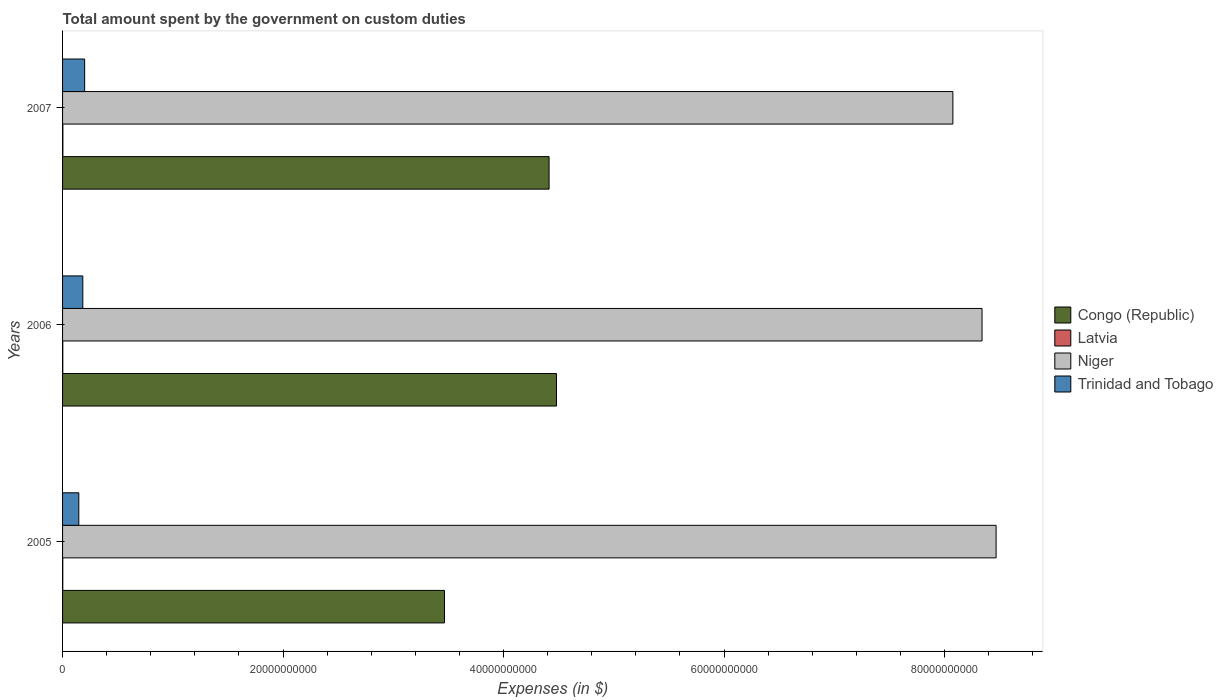Are the number of bars on each tick of the Y-axis equal?
Keep it short and to the point. Yes. How many bars are there on the 2nd tick from the bottom?
Your response must be concise. 4. What is the label of the 3rd group of bars from the top?
Your answer should be compact. 2005. In how many cases, is the number of bars for a given year not equal to the number of legend labels?
Your answer should be compact. 0. What is the amount spent on custom duties by the government in Congo (Republic) in 2005?
Offer a very short reply. 3.46e+1. Across all years, what is the maximum amount spent on custom duties by the government in Niger?
Keep it short and to the point. 8.47e+1. Across all years, what is the minimum amount spent on custom duties by the government in Congo (Republic)?
Your answer should be very brief. 3.46e+1. In which year was the amount spent on custom duties by the government in Congo (Republic) maximum?
Offer a very short reply. 2006. In which year was the amount spent on custom duties by the government in Congo (Republic) minimum?
Your answer should be compact. 2005. What is the total amount spent on custom duties by the government in Trinidad and Tobago in the graph?
Offer a very short reply. 5.31e+09. What is the difference between the amount spent on custom duties by the government in Congo (Republic) in 2005 and that in 2007?
Your answer should be very brief. -9.48e+09. What is the difference between the amount spent on custom duties by the government in Congo (Republic) in 2005 and the amount spent on custom duties by the government in Trinidad and Tobago in 2007?
Offer a very short reply. 3.26e+1. What is the average amount spent on custom duties by the government in Latvia per year?
Provide a short and direct response. 2.26e+07. In the year 2005, what is the difference between the amount spent on custom duties by the government in Niger and amount spent on custom duties by the government in Latvia?
Offer a terse response. 8.47e+1. In how many years, is the amount spent on custom duties by the government in Niger greater than 12000000000 $?
Your answer should be very brief. 3. What is the ratio of the amount spent on custom duties by the government in Trinidad and Tobago in 2005 to that in 2006?
Make the answer very short. 0.8. What is the difference between the highest and the second highest amount spent on custom duties by the government in Latvia?
Offer a very short reply. 7.14e+06. What is the difference between the highest and the lowest amount spent on custom duties by the government in Niger?
Ensure brevity in your answer.  3.92e+09. In how many years, is the amount spent on custom duties by the government in Niger greater than the average amount spent on custom duties by the government in Niger taken over all years?
Your answer should be compact. 2. Is it the case that in every year, the sum of the amount spent on custom duties by the government in Congo (Republic) and amount spent on custom duties by the government in Latvia is greater than the sum of amount spent on custom duties by the government in Niger and amount spent on custom duties by the government in Trinidad and Tobago?
Provide a succinct answer. Yes. What does the 3rd bar from the top in 2005 represents?
Your answer should be very brief. Latvia. What does the 1st bar from the bottom in 2005 represents?
Keep it short and to the point. Congo (Republic). Is it the case that in every year, the sum of the amount spent on custom duties by the government in Trinidad and Tobago and amount spent on custom duties by the government in Niger is greater than the amount spent on custom duties by the government in Latvia?
Offer a terse response. Yes. How many bars are there?
Make the answer very short. 12. What is the difference between two consecutive major ticks on the X-axis?
Give a very brief answer. 2.00e+1. Where does the legend appear in the graph?
Offer a very short reply. Center right. How many legend labels are there?
Keep it short and to the point. 4. What is the title of the graph?
Offer a very short reply. Total amount spent by the government on custom duties. Does "Mauritius" appear as one of the legend labels in the graph?
Offer a terse response. No. What is the label or title of the X-axis?
Make the answer very short. Expenses (in $). What is the Expenses (in $) in Congo (Republic) in 2005?
Keep it short and to the point. 3.46e+1. What is the Expenses (in $) of Latvia in 2005?
Provide a short and direct response. 1.92e+07. What is the Expenses (in $) of Niger in 2005?
Your response must be concise. 8.47e+1. What is the Expenses (in $) of Trinidad and Tobago in 2005?
Your answer should be very brief. 1.47e+09. What is the Expenses (in $) of Congo (Republic) in 2006?
Your response must be concise. 4.48e+1. What is the Expenses (in $) of Latvia in 2006?
Your answer should be very brief. 2.07e+07. What is the Expenses (in $) of Niger in 2006?
Make the answer very short. 8.34e+1. What is the Expenses (in $) of Trinidad and Tobago in 2006?
Offer a terse response. 1.84e+09. What is the Expenses (in $) of Congo (Republic) in 2007?
Provide a short and direct response. 4.41e+1. What is the Expenses (in $) in Latvia in 2007?
Your answer should be very brief. 2.78e+07. What is the Expenses (in $) in Niger in 2007?
Your answer should be compact. 8.08e+1. What is the Expenses (in $) in Trinidad and Tobago in 2007?
Offer a very short reply. 2.00e+09. Across all years, what is the maximum Expenses (in $) in Congo (Republic)?
Offer a terse response. 4.48e+1. Across all years, what is the maximum Expenses (in $) of Latvia?
Your response must be concise. 2.78e+07. Across all years, what is the maximum Expenses (in $) of Niger?
Make the answer very short. 8.47e+1. Across all years, what is the maximum Expenses (in $) in Trinidad and Tobago?
Offer a very short reply. 2.00e+09. Across all years, what is the minimum Expenses (in $) of Congo (Republic)?
Give a very brief answer. 3.46e+1. Across all years, what is the minimum Expenses (in $) in Latvia?
Your answer should be very brief. 1.92e+07. Across all years, what is the minimum Expenses (in $) of Niger?
Offer a terse response. 8.08e+1. Across all years, what is the minimum Expenses (in $) of Trinidad and Tobago?
Keep it short and to the point. 1.47e+09. What is the total Expenses (in $) in Congo (Republic) in the graph?
Keep it short and to the point. 1.24e+11. What is the total Expenses (in $) in Latvia in the graph?
Your answer should be compact. 6.77e+07. What is the total Expenses (in $) of Niger in the graph?
Your answer should be very brief. 2.49e+11. What is the total Expenses (in $) of Trinidad and Tobago in the graph?
Offer a terse response. 5.31e+09. What is the difference between the Expenses (in $) of Congo (Republic) in 2005 and that in 2006?
Provide a short and direct response. -1.02e+1. What is the difference between the Expenses (in $) in Latvia in 2005 and that in 2006?
Ensure brevity in your answer.  -1.50e+06. What is the difference between the Expenses (in $) in Niger in 2005 and that in 2006?
Give a very brief answer. 1.28e+09. What is the difference between the Expenses (in $) of Trinidad and Tobago in 2005 and that in 2006?
Keep it short and to the point. -3.63e+08. What is the difference between the Expenses (in $) in Congo (Republic) in 2005 and that in 2007?
Offer a terse response. -9.48e+09. What is the difference between the Expenses (in $) of Latvia in 2005 and that in 2007?
Give a very brief answer. -8.64e+06. What is the difference between the Expenses (in $) of Niger in 2005 and that in 2007?
Your response must be concise. 3.92e+09. What is the difference between the Expenses (in $) in Trinidad and Tobago in 2005 and that in 2007?
Give a very brief answer. -5.31e+08. What is the difference between the Expenses (in $) in Congo (Republic) in 2006 and that in 2007?
Your response must be concise. 6.73e+08. What is the difference between the Expenses (in $) of Latvia in 2006 and that in 2007?
Offer a very short reply. -7.14e+06. What is the difference between the Expenses (in $) in Niger in 2006 and that in 2007?
Your answer should be very brief. 2.65e+09. What is the difference between the Expenses (in $) of Trinidad and Tobago in 2006 and that in 2007?
Ensure brevity in your answer.  -1.68e+08. What is the difference between the Expenses (in $) of Congo (Republic) in 2005 and the Expenses (in $) of Latvia in 2006?
Offer a very short reply. 3.46e+1. What is the difference between the Expenses (in $) of Congo (Republic) in 2005 and the Expenses (in $) of Niger in 2006?
Your response must be concise. -4.88e+1. What is the difference between the Expenses (in $) of Congo (Republic) in 2005 and the Expenses (in $) of Trinidad and Tobago in 2006?
Keep it short and to the point. 3.28e+1. What is the difference between the Expenses (in $) in Latvia in 2005 and the Expenses (in $) in Niger in 2006?
Offer a very short reply. -8.34e+1. What is the difference between the Expenses (in $) in Latvia in 2005 and the Expenses (in $) in Trinidad and Tobago in 2006?
Offer a terse response. -1.82e+09. What is the difference between the Expenses (in $) of Niger in 2005 and the Expenses (in $) of Trinidad and Tobago in 2006?
Provide a short and direct response. 8.28e+1. What is the difference between the Expenses (in $) in Congo (Republic) in 2005 and the Expenses (in $) in Latvia in 2007?
Provide a short and direct response. 3.46e+1. What is the difference between the Expenses (in $) in Congo (Republic) in 2005 and the Expenses (in $) in Niger in 2007?
Provide a succinct answer. -4.61e+1. What is the difference between the Expenses (in $) of Congo (Republic) in 2005 and the Expenses (in $) of Trinidad and Tobago in 2007?
Offer a very short reply. 3.26e+1. What is the difference between the Expenses (in $) of Latvia in 2005 and the Expenses (in $) of Niger in 2007?
Offer a terse response. -8.07e+1. What is the difference between the Expenses (in $) of Latvia in 2005 and the Expenses (in $) of Trinidad and Tobago in 2007?
Ensure brevity in your answer.  -1.98e+09. What is the difference between the Expenses (in $) in Niger in 2005 and the Expenses (in $) in Trinidad and Tobago in 2007?
Offer a terse response. 8.27e+1. What is the difference between the Expenses (in $) in Congo (Republic) in 2006 and the Expenses (in $) in Latvia in 2007?
Offer a terse response. 4.48e+1. What is the difference between the Expenses (in $) of Congo (Republic) in 2006 and the Expenses (in $) of Niger in 2007?
Offer a very short reply. -3.60e+1. What is the difference between the Expenses (in $) of Congo (Republic) in 2006 and the Expenses (in $) of Trinidad and Tobago in 2007?
Your answer should be very brief. 4.28e+1. What is the difference between the Expenses (in $) in Latvia in 2006 and the Expenses (in $) in Niger in 2007?
Your answer should be very brief. -8.07e+1. What is the difference between the Expenses (in $) in Latvia in 2006 and the Expenses (in $) in Trinidad and Tobago in 2007?
Give a very brief answer. -1.98e+09. What is the difference between the Expenses (in $) of Niger in 2006 and the Expenses (in $) of Trinidad and Tobago in 2007?
Keep it short and to the point. 8.14e+1. What is the average Expenses (in $) in Congo (Republic) per year?
Make the answer very short. 4.12e+1. What is the average Expenses (in $) of Latvia per year?
Your answer should be compact. 2.26e+07. What is the average Expenses (in $) in Niger per year?
Ensure brevity in your answer.  8.29e+1. What is the average Expenses (in $) of Trinidad and Tobago per year?
Offer a very short reply. 1.77e+09. In the year 2005, what is the difference between the Expenses (in $) of Congo (Republic) and Expenses (in $) of Latvia?
Give a very brief answer. 3.46e+1. In the year 2005, what is the difference between the Expenses (in $) of Congo (Republic) and Expenses (in $) of Niger?
Provide a succinct answer. -5.00e+1. In the year 2005, what is the difference between the Expenses (in $) of Congo (Republic) and Expenses (in $) of Trinidad and Tobago?
Make the answer very short. 3.32e+1. In the year 2005, what is the difference between the Expenses (in $) in Latvia and Expenses (in $) in Niger?
Your response must be concise. -8.47e+1. In the year 2005, what is the difference between the Expenses (in $) of Latvia and Expenses (in $) of Trinidad and Tobago?
Make the answer very short. -1.45e+09. In the year 2005, what is the difference between the Expenses (in $) in Niger and Expenses (in $) in Trinidad and Tobago?
Keep it short and to the point. 8.32e+1. In the year 2006, what is the difference between the Expenses (in $) in Congo (Republic) and Expenses (in $) in Latvia?
Your response must be concise. 4.48e+1. In the year 2006, what is the difference between the Expenses (in $) of Congo (Republic) and Expenses (in $) of Niger?
Your answer should be very brief. -3.86e+1. In the year 2006, what is the difference between the Expenses (in $) of Congo (Republic) and Expenses (in $) of Trinidad and Tobago?
Provide a succinct answer. 4.30e+1. In the year 2006, what is the difference between the Expenses (in $) in Latvia and Expenses (in $) in Niger?
Keep it short and to the point. -8.34e+1. In the year 2006, what is the difference between the Expenses (in $) in Latvia and Expenses (in $) in Trinidad and Tobago?
Provide a succinct answer. -1.82e+09. In the year 2006, what is the difference between the Expenses (in $) of Niger and Expenses (in $) of Trinidad and Tobago?
Give a very brief answer. 8.16e+1. In the year 2007, what is the difference between the Expenses (in $) in Congo (Republic) and Expenses (in $) in Latvia?
Offer a terse response. 4.41e+1. In the year 2007, what is the difference between the Expenses (in $) in Congo (Republic) and Expenses (in $) in Niger?
Give a very brief answer. -3.66e+1. In the year 2007, what is the difference between the Expenses (in $) of Congo (Republic) and Expenses (in $) of Trinidad and Tobago?
Provide a succinct answer. 4.21e+1. In the year 2007, what is the difference between the Expenses (in $) of Latvia and Expenses (in $) of Niger?
Provide a succinct answer. -8.07e+1. In the year 2007, what is the difference between the Expenses (in $) in Latvia and Expenses (in $) in Trinidad and Tobago?
Offer a terse response. -1.98e+09. In the year 2007, what is the difference between the Expenses (in $) of Niger and Expenses (in $) of Trinidad and Tobago?
Keep it short and to the point. 7.87e+1. What is the ratio of the Expenses (in $) of Congo (Republic) in 2005 to that in 2006?
Ensure brevity in your answer.  0.77. What is the ratio of the Expenses (in $) in Latvia in 2005 to that in 2006?
Offer a very short reply. 0.93. What is the ratio of the Expenses (in $) of Niger in 2005 to that in 2006?
Your response must be concise. 1.02. What is the ratio of the Expenses (in $) of Trinidad and Tobago in 2005 to that in 2006?
Give a very brief answer. 0.8. What is the ratio of the Expenses (in $) of Congo (Republic) in 2005 to that in 2007?
Offer a very short reply. 0.79. What is the ratio of the Expenses (in $) in Latvia in 2005 to that in 2007?
Keep it short and to the point. 0.69. What is the ratio of the Expenses (in $) of Niger in 2005 to that in 2007?
Keep it short and to the point. 1.05. What is the ratio of the Expenses (in $) of Trinidad and Tobago in 2005 to that in 2007?
Offer a terse response. 0.74. What is the ratio of the Expenses (in $) of Congo (Republic) in 2006 to that in 2007?
Offer a very short reply. 1.02. What is the ratio of the Expenses (in $) of Latvia in 2006 to that in 2007?
Make the answer very short. 0.74. What is the ratio of the Expenses (in $) of Niger in 2006 to that in 2007?
Your answer should be very brief. 1.03. What is the ratio of the Expenses (in $) of Trinidad and Tobago in 2006 to that in 2007?
Ensure brevity in your answer.  0.92. What is the difference between the highest and the second highest Expenses (in $) of Congo (Republic)?
Your response must be concise. 6.73e+08. What is the difference between the highest and the second highest Expenses (in $) in Latvia?
Offer a very short reply. 7.14e+06. What is the difference between the highest and the second highest Expenses (in $) in Niger?
Offer a terse response. 1.28e+09. What is the difference between the highest and the second highest Expenses (in $) in Trinidad and Tobago?
Provide a succinct answer. 1.68e+08. What is the difference between the highest and the lowest Expenses (in $) of Congo (Republic)?
Your answer should be very brief. 1.02e+1. What is the difference between the highest and the lowest Expenses (in $) of Latvia?
Give a very brief answer. 8.64e+06. What is the difference between the highest and the lowest Expenses (in $) of Niger?
Your response must be concise. 3.92e+09. What is the difference between the highest and the lowest Expenses (in $) of Trinidad and Tobago?
Make the answer very short. 5.31e+08. 